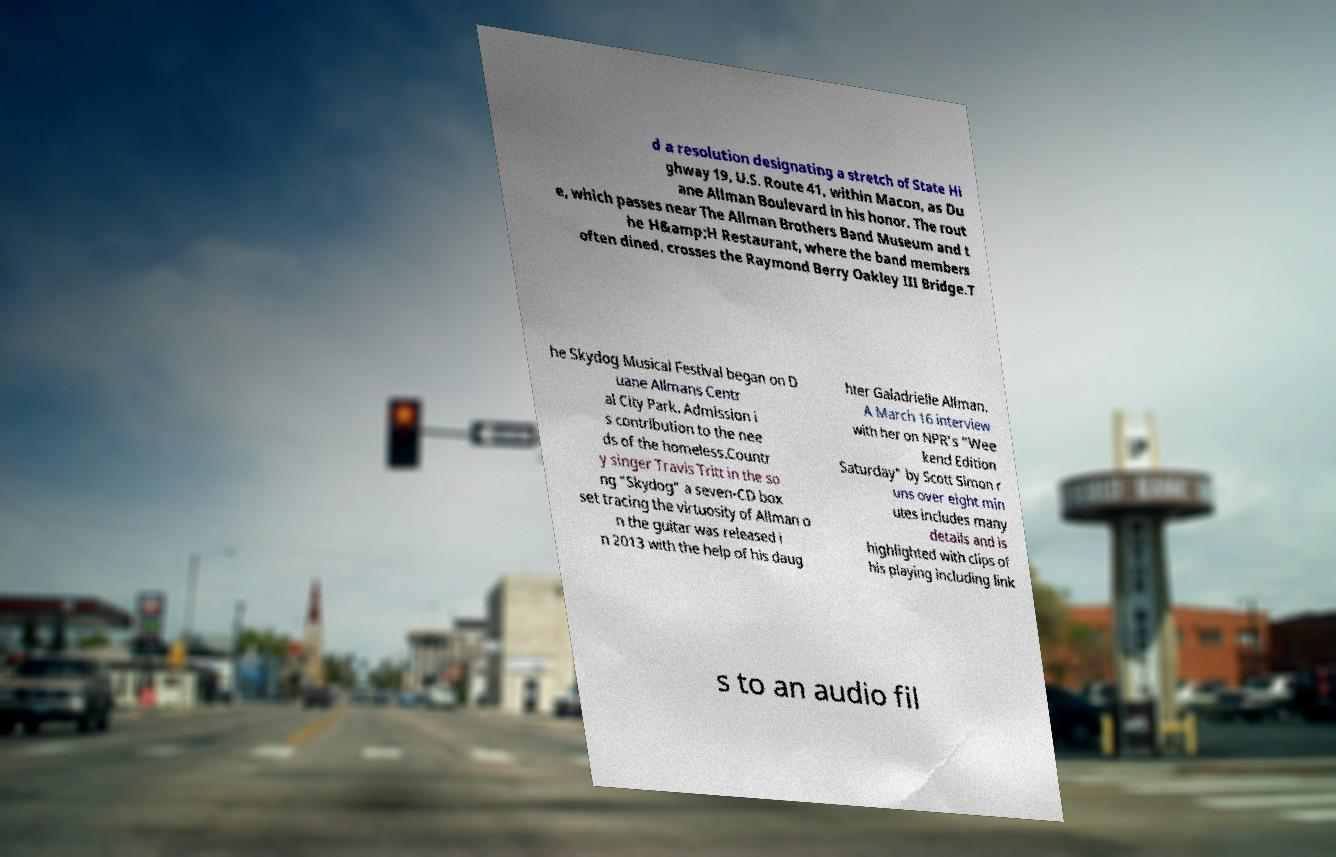Please read and relay the text visible in this image. What does it say? d a resolution designating a stretch of State Hi ghway 19, U.S. Route 41, within Macon, as Du ane Allman Boulevard in his honor. The rout e, which passes near The Allman Brothers Band Museum and t he H&amp;H Restaurant, where the band members often dined, crosses the Raymond Berry Oakley III Bridge.T he Skydog Musical Festival began on D uane Allmans Centr al City Park. Admission i s contribution to the nee ds of the homeless.Countr y singer Travis Tritt in the so ng "Skydog" a seven-CD box set tracing the virtuosity of Allman o n the guitar was released i n 2013 with the help of his daug hter Galadrielle Allman. A March 16 interview with her on NPR's "Wee kend Edition Saturday" by Scott Simon r uns over eight min utes includes many details and is highlighted with clips of his playing including link s to an audio fil 